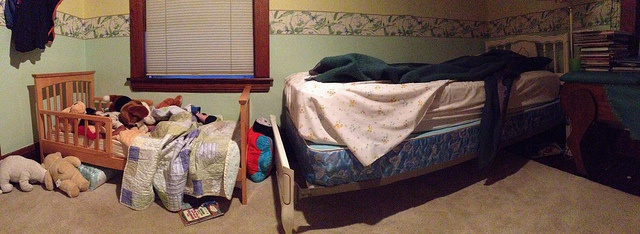Describe the objects in this image and their specific colors. I can see bed in tan, black, lightgray, and gray tones, teddy bear in tan, gray, and maroon tones, teddy bear in tan and gray tones, book in tan, brown, maroon, and black tones, and teddy bear in tan, maroon, black, and brown tones in this image. 